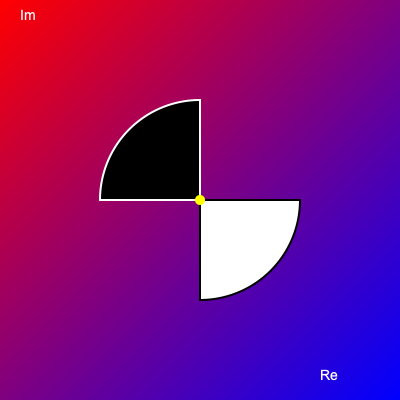The image above represents a fractal-inspired visualization of the complex plane. If this pattern were to continue infinitely, how would the relationship between the fractal's self-similarity and the properties of complex numbers in the regions $z$ where $|z| > 1$ be best described in terms of cognitive processing? To answer this question, we need to consider several cognitive aspects related to both fractal visualization and complex number theory:

1. Fractal self-similarity:
   - The image shows a basic Yin-Yang-like pattern that suggests infinite repetition.
   - Cognitively, this requires the ability to visualize and extrapolate patterns.

2. Complex plane representation:
   - The gradient background represents the complex plane.
   - The horizontal axis (labeled "Re") represents real numbers.
   - The vertical axis (labeled "Im") represents imaginary numbers.

3. Regions where $|z| > 1$:
   - This refers to points outside the unit circle in the complex plane.
   - In the fractal representation, this would correspond to the outer regions of the pattern.

4. Cognitive processing of these concepts:
   - Pattern recognition: Identifying the repeating elements in the fractal.
   - Spatial reasoning: Understanding how the pattern relates to the complex plane.
   - Abstract thinking: Connecting the visual representation to mathematical concepts.

5. Relationship between fractals and complex numbers:
   - Fractals often arise from iterative processes involving complex numbers.
   - The Mandelbrot set, for example, is defined by iterations of $z_{n+1} = z_n^2 + c$ in the complex plane.

6. Cognitive link:
   - The self-similarity of the fractal in regions where $|z| > 1$ could represent the divergent behavior of complex functions in these regions.
   - This requires integrating visual-spatial processing with abstract mathematical concepts.

Given these considerations, the relationship between the fractal's self-similarity and complex number properties in $|z| > 1$ regions would best be described as a cognitive process that integrates visual-spatial pattern recognition with abstract mathematical reasoning, allowing for the conceptualization of infinite complexity through finite representational structures.
Answer: Integration of visual-spatial pattern recognition and abstract mathematical reasoning 